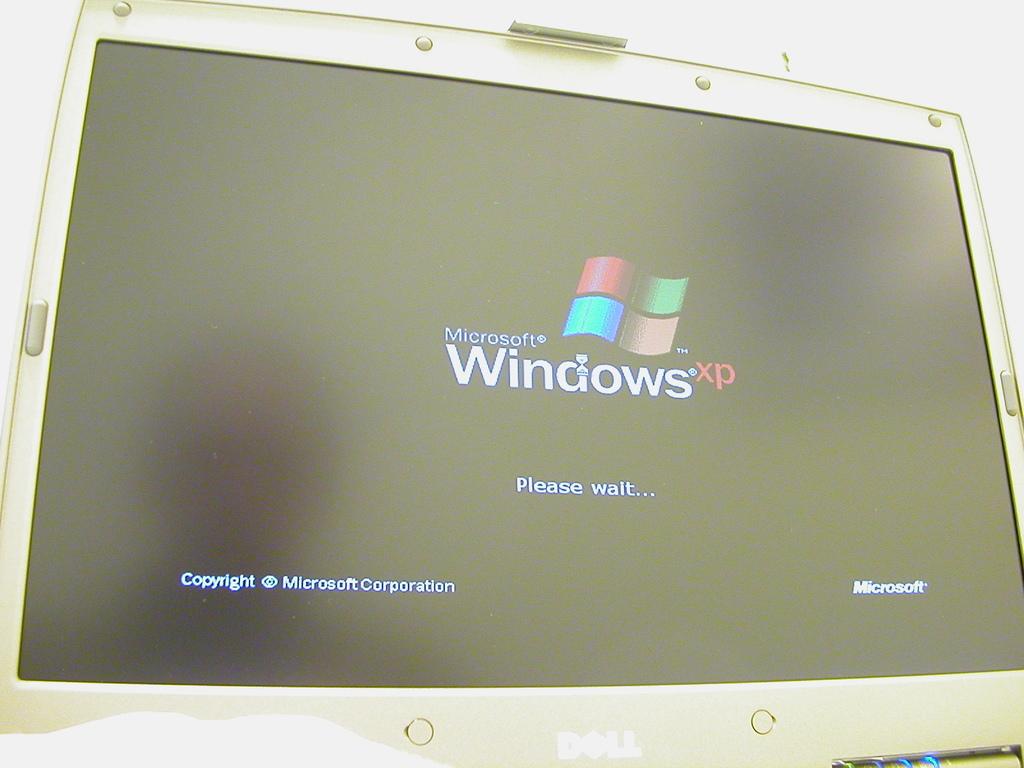Which operating system is this?
Provide a succinct answer. Windows xp. What brand is the computer monitor?
Ensure brevity in your answer.  Dell. 